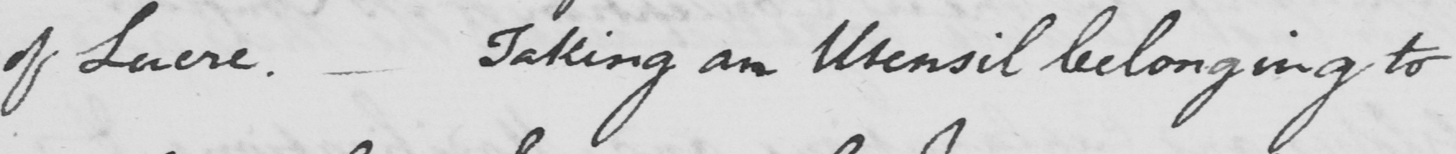Can you tell me what this handwritten text says? of Lucre . Taking an Utensil belonging to 